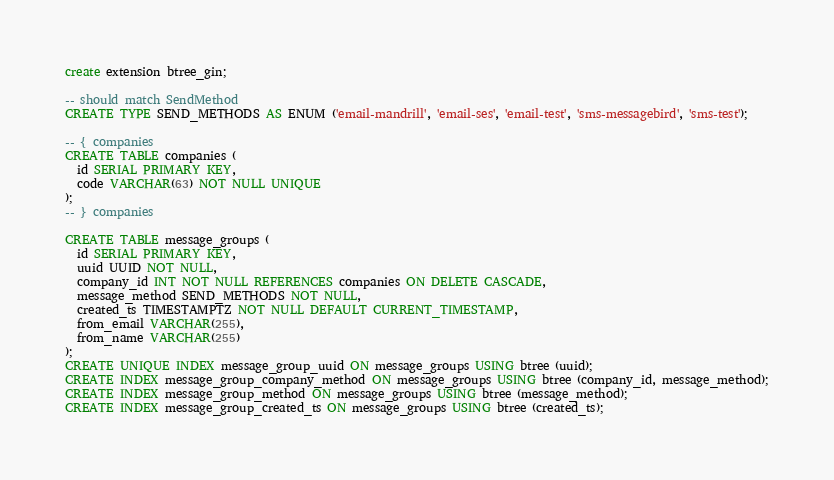Convert code to text. <code><loc_0><loc_0><loc_500><loc_500><_SQL_>create extension btree_gin;

-- should match SendMethod
CREATE TYPE SEND_METHODS AS ENUM ('email-mandrill', 'email-ses', 'email-test', 'sms-messagebird', 'sms-test');

-- { companies
CREATE TABLE companies (
  id SERIAL PRIMARY KEY,
  code VARCHAR(63) NOT NULL UNIQUE
);
-- } companies

CREATE TABLE message_groups (
  id SERIAL PRIMARY KEY,
  uuid UUID NOT NULL,
  company_id INT NOT NULL REFERENCES companies ON DELETE CASCADE,
  message_method SEND_METHODS NOT NULL,
  created_ts TIMESTAMPTZ NOT NULL DEFAULT CURRENT_TIMESTAMP,
  from_email VARCHAR(255),
  from_name VARCHAR(255)
);
CREATE UNIQUE INDEX message_group_uuid ON message_groups USING btree (uuid);
CREATE INDEX message_group_company_method ON message_groups USING btree (company_id, message_method);
CREATE INDEX message_group_method ON message_groups USING btree (message_method);
CREATE INDEX message_group_created_ts ON message_groups USING btree (created_ts);</code> 